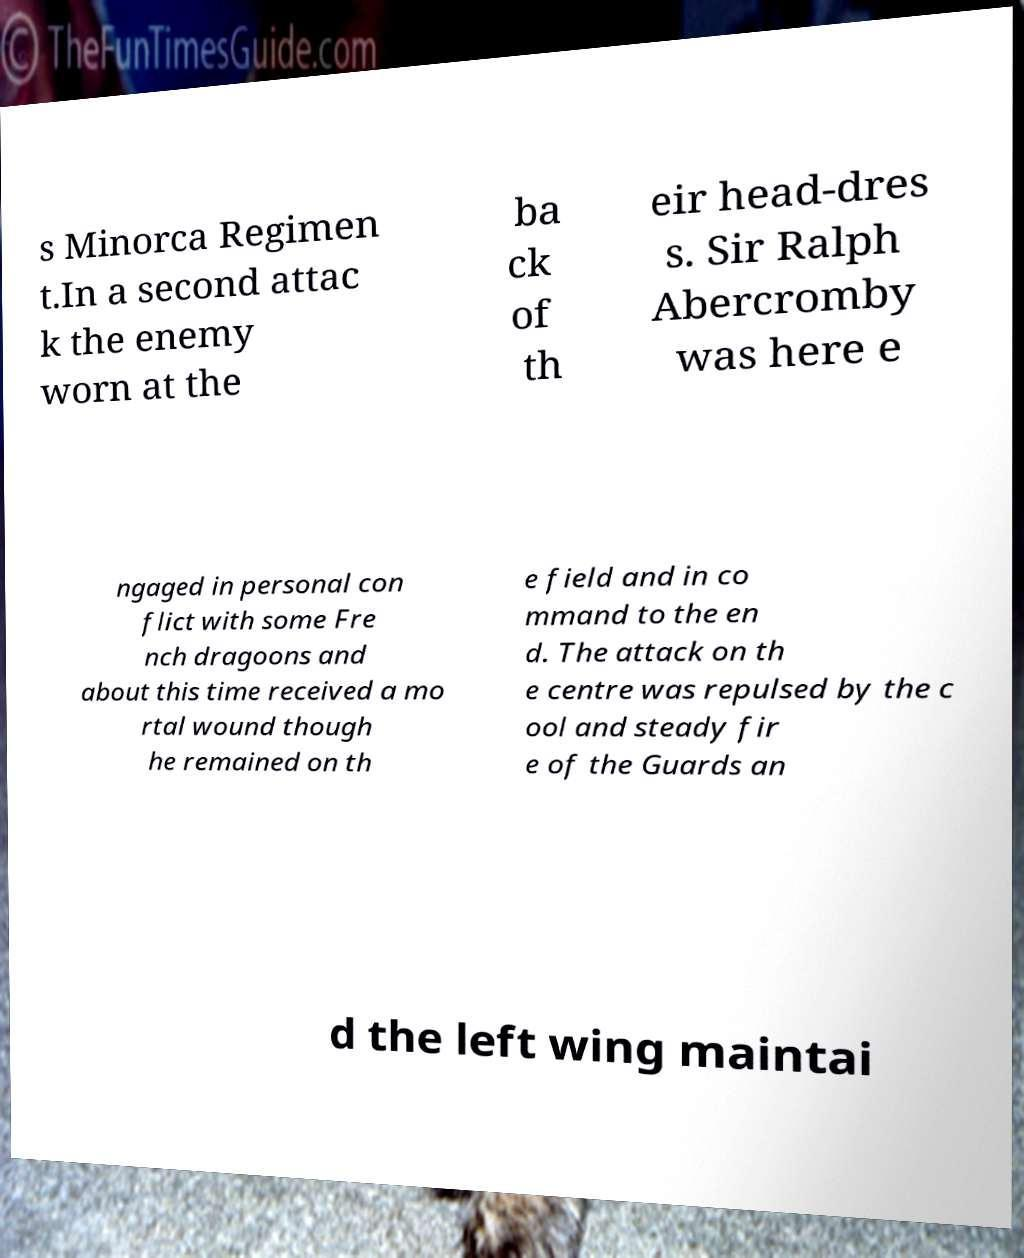There's text embedded in this image that I need extracted. Can you transcribe it verbatim? s Minorca Regimen t.In a second attac k the enemy worn at the ba ck of th eir head-dres s. Sir Ralph Abercromby was here e ngaged in personal con flict with some Fre nch dragoons and about this time received a mo rtal wound though he remained on th e field and in co mmand to the en d. The attack on th e centre was repulsed by the c ool and steady fir e of the Guards an d the left wing maintai 